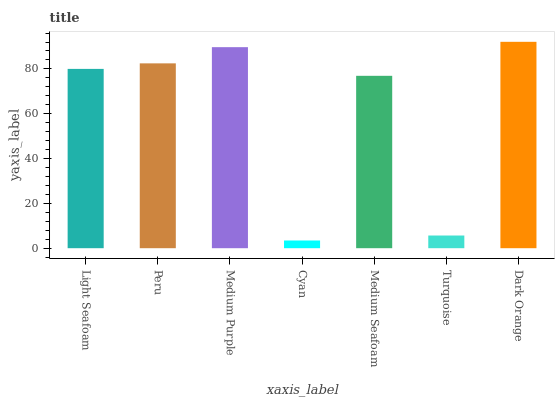Is Cyan the minimum?
Answer yes or no. Yes. Is Dark Orange the maximum?
Answer yes or no. Yes. Is Peru the minimum?
Answer yes or no. No. Is Peru the maximum?
Answer yes or no. No. Is Peru greater than Light Seafoam?
Answer yes or no. Yes. Is Light Seafoam less than Peru?
Answer yes or no. Yes. Is Light Seafoam greater than Peru?
Answer yes or no. No. Is Peru less than Light Seafoam?
Answer yes or no. No. Is Light Seafoam the high median?
Answer yes or no. Yes. Is Light Seafoam the low median?
Answer yes or no. Yes. Is Peru the high median?
Answer yes or no. No. Is Medium Seafoam the low median?
Answer yes or no. No. 